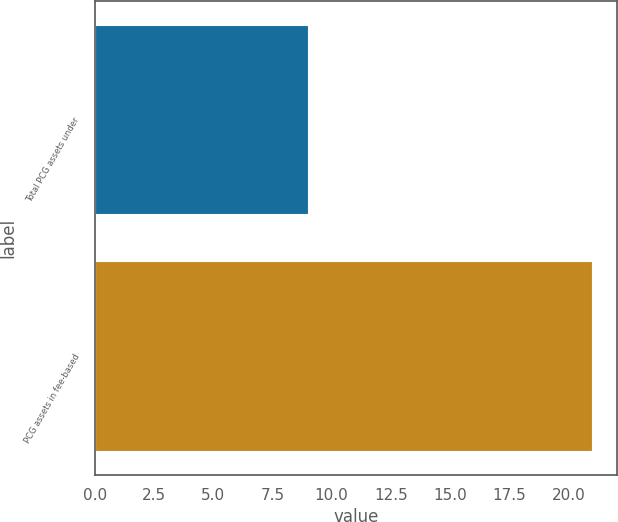Convert chart to OTSL. <chart><loc_0><loc_0><loc_500><loc_500><bar_chart><fcel>Total PCG assets under<fcel>PCG assets in fee-based<nl><fcel>9<fcel>21<nl></chart> 